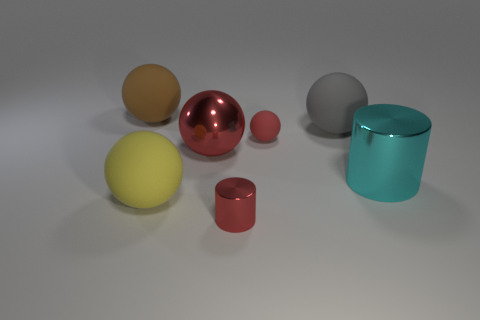How big is the rubber ball that is in front of the tiny ball?
Make the answer very short. Large. Is the number of red matte spheres greater than the number of big things?
Offer a terse response. No. What is the small red cylinder made of?
Give a very brief answer. Metal. What number of other objects are there of the same material as the red cylinder?
Offer a very short reply. 2. What number of cyan objects are there?
Provide a short and direct response. 1. There is a small red thing that is the same shape as the big gray rubber thing; what is it made of?
Make the answer very short. Rubber. Are the big sphere behind the gray thing and the large yellow object made of the same material?
Keep it short and to the point. Yes. Are there more small spheres left of the large brown thing than spheres that are to the left of the yellow sphere?
Offer a terse response. No. How big is the red rubber ball?
Your response must be concise. Small. What is the shape of the big yellow thing that is made of the same material as the small sphere?
Provide a succinct answer. Sphere. 